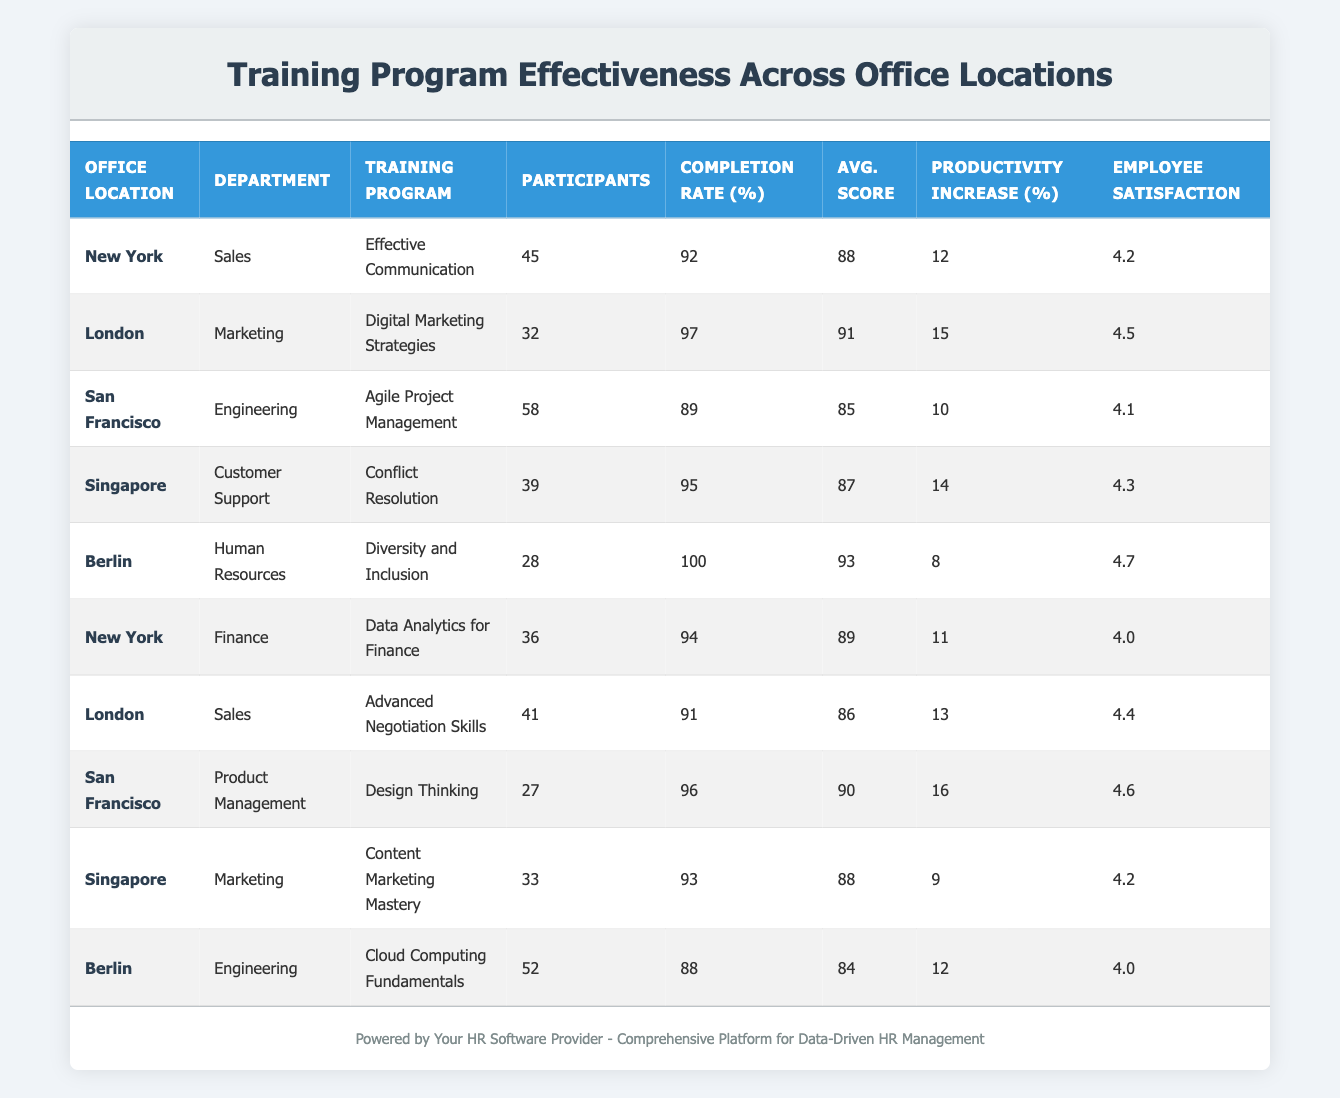What is the completion rate for the training program "Effective Communication" in New York? The table shows the completion rate for the "Effective Communication" training program under the New York office location as 92%.
Answer: 92 Which office location had the highest average score among participants? From the table, Berlin has the highest average score of 93 for the "Diversity and Inclusion" program.
Answer: 93 What is the total participant count across all training programs held in San Francisco? The participant counts for San Francisco are 58 for "Agile Project Management" and 27 for "Design Thinking." Adding these gives 58 + 27 = 85 participants.
Answer: 85 Did the London office have a training program with 100% completion rate? The table indicates that no training program in the London office has a completion rate of 100%.
Answer: No What is the average employee satisfaction score for training programs held in Singapore? The employee satisfaction scores for Singapore are 4.3 for "Conflict Resolution" and 4.2 for "Content Marketing Mastery." The average is (4.3 + 4.2) / 2 = 4.25.
Answer: 4.25 Which training program in Berlin had the lowest productivity increase percentage? The table shows that the "Diversity and Inclusion" program in Berlin had a productivity increase of 8%, while "Cloud Computing Fundamentals" had 12%. Thus, "Diversity and Inclusion" has the lowest productivity increase percentage.
Answer: 8 How many training programs in total were conducted in New York? In New York, there are two training programs: "Effective Communication" and "Data Analytics for Finance." Thus, the total number is 2.
Answer: 2 What is the difference in productivity increase between the "Digital Marketing Strategies" program in London and the "Conflict Resolution" program in Singapore? The productivity increase for "Digital Marketing Strategies" is 15% in London, and for "Conflict Resolution," it is 14% in Singapore. The difference is 15 - 14 = 1%.
Answer: 1 Which department in Berlin participated in the most training programs, and how many were conducted? The table indicates that there are two programs conducted in Berlin: "Diversity and Inclusion" for Human Resources and "Cloud Computing Fundamentals" for Engineering, therefore both departments participated in 1 program each.
Answer: 1 